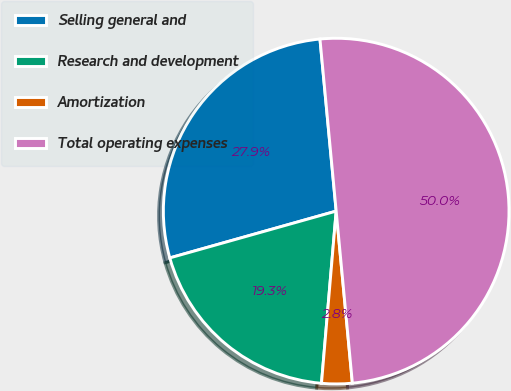<chart> <loc_0><loc_0><loc_500><loc_500><pie_chart><fcel>Selling general and<fcel>Research and development<fcel>Amortization<fcel>Total operating expenses<nl><fcel>27.87%<fcel>19.28%<fcel>2.85%<fcel>50.0%<nl></chart> 